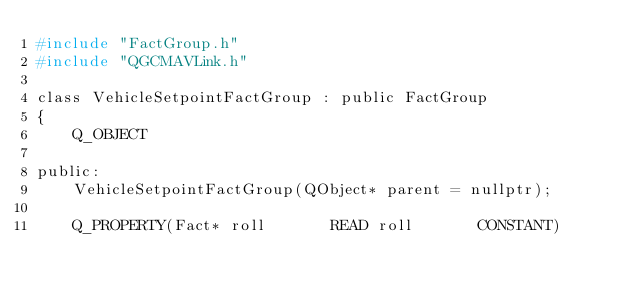Convert code to text. <code><loc_0><loc_0><loc_500><loc_500><_C_>#include "FactGroup.h"
#include "QGCMAVLink.h"

class VehicleSetpointFactGroup : public FactGroup
{
    Q_OBJECT

public:
    VehicleSetpointFactGroup(QObject* parent = nullptr);

    Q_PROPERTY(Fact* roll       READ roll       CONSTANT)</code> 